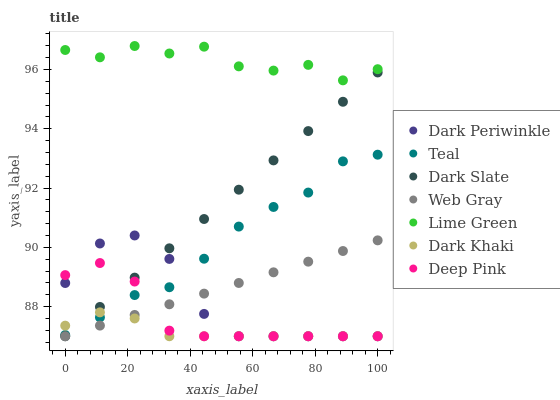Does Dark Khaki have the minimum area under the curve?
Answer yes or no. Yes. Does Lime Green have the maximum area under the curve?
Answer yes or no. Yes. Does Dark Slate have the minimum area under the curve?
Answer yes or no. No. Does Dark Slate have the maximum area under the curve?
Answer yes or no. No. Is Web Gray the smoothest?
Answer yes or no. Yes. Is Lime Green the roughest?
Answer yes or no. Yes. Is Dark Khaki the smoothest?
Answer yes or no. No. Is Dark Khaki the roughest?
Answer yes or no. No. Does Web Gray have the lowest value?
Answer yes or no. Yes. Does Teal have the lowest value?
Answer yes or no. No. Does Lime Green have the highest value?
Answer yes or no. Yes. Does Dark Slate have the highest value?
Answer yes or no. No. Is Dark Slate less than Lime Green?
Answer yes or no. Yes. Is Lime Green greater than Dark Khaki?
Answer yes or no. Yes. Does Dark Slate intersect Deep Pink?
Answer yes or no. Yes. Is Dark Slate less than Deep Pink?
Answer yes or no. No. Is Dark Slate greater than Deep Pink?
Answer yes or no. No. Does Dark Slate intersect Lime Green?
Answer yes or no. No. 